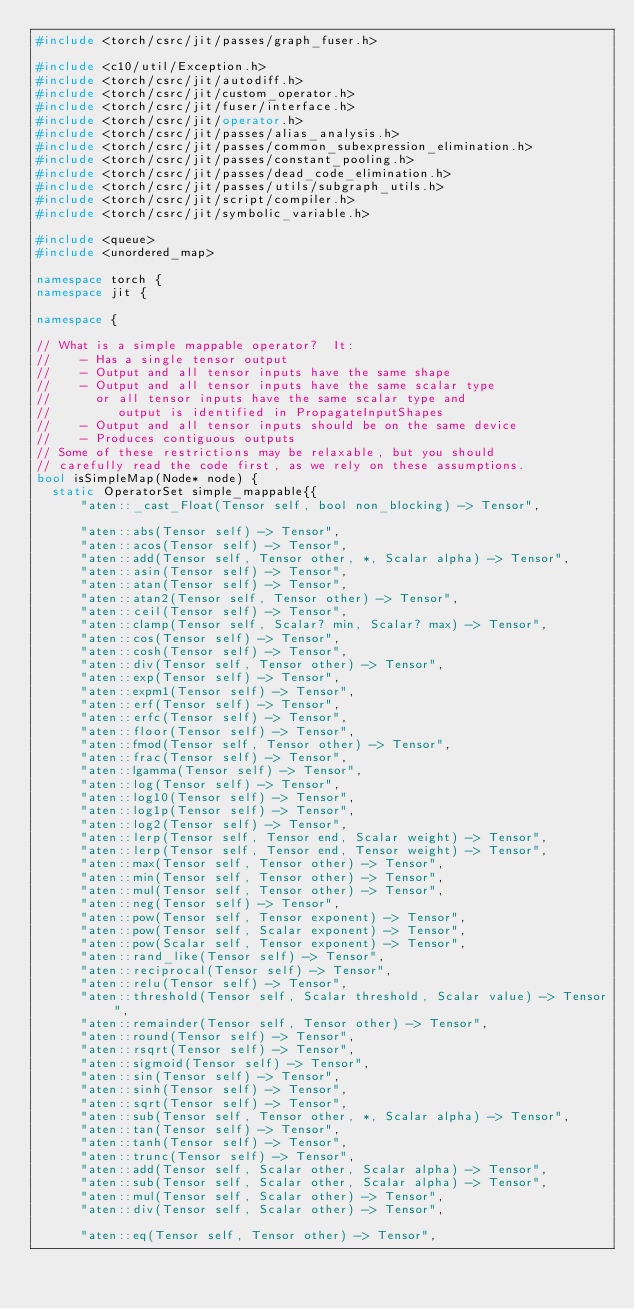Convert code to text. <code><loc_0><loc_0><loc_500><loc_500><_C++_>#include <torch/csrc/jit/passes/graph_fuser.h>

#include <c10/util/Exception.h>
#include <torch/csrc/jit/autodiff.h>
#include <torch/csrc/jit/custom_operator.h>
#include <torch/csrc/jit/fuser/interface.h>
#include <torch/csrc/jit/operator.h>
#include <torch/csrc/jit/passes/alias_analysis.h>
#include <torch/csrc/jit/passes/common_subexpression_elimination.h>
#include <torch/csrc/jit/passes/constant_pooling.h>
#include <torch/csrc/jit/passes/dead_code_elimination.h>
#include <torch/csrc/jit/passes/utils/subgraph_utils.h>
#include <torch/csrc/jit/script/compiler.h>
#include <torch/csrc/jit/symbolic_variable.h>

#include <queue>
#include <unordered_map>

namespace torch {
namespace jit {

namespace {

// What is a simple mappable operator?  It:
//    - Has a single tensor output
//    - Output and all tensor inputs have the same shape
//    - Output and all tensor inputs have the same scalar type
//      or all tensor inputs have the same scalar type and
//         output is identified in PropagateInputShapes
//    - Output and all tensor inputs should be on the same device
//    - Produces contiguous outputs
// Some of these restrictions may be relaxable, but you should
// carefully read the code first, as we rely on these assumptions.
bool isSimpleMap(Node* node) {
  static OperatorSet simple_mappable{{
      "aten::_cast_Float(Tensor self, bool non_blocking) -> Tensor",

      "aten::abs(Tensor self) -> Tensor",
      "aten::acos(Tensor self) -> Tensor",
      "aten::add(Tensor self, Tensor other, *, Scalar alpha) -> Tensor",
      "aten::asin(Tensor self) -> Tensor",
      "aten::atan(Tensor self) -> Tensor",
      "aten::atan2(Tensor self, Tensor other) -> Tensor",
      "aten::ceil(Tensor self) -> Tensor",
      "aten::clamp(Tensor self, Scalar? min, Scalar? max) -> Tensor",
      "aten::cos(Tensor self) -> Tensor",
      "aten::cosh(Tensor self) -> Tensor",
      "aten::div(Tensor self, Tensor other) -> Tensor",
      "aten::exp(Tensor self) -> Tensor",
      "aten::expm1(Tensor self) -> Tensor",
      "aten::erf(Tensor self) -> Tensor",
      "aten::erfc(Tensor self) -> Tensor",
      "aten::floor(Tensor self) -> Tensor",
      "aten::fmod(Tensor self, Tensor other) -> Tensor",
      "aten::frac(Tensor self) -> Tensor",
      "aten::lgamma(Tensor self) -> Tensor",
      "aten::log(Tensor self) -> Tensor",
      "aten::log10(Tensor self) -> Tensor",
      "aten::log1p(Tensor self) -> Tensor",
      "aten::log2(Tensor self) -> Tensor",
      "aten::lerp(Tensor self, Tensor end, Scalar weight) -> Tensor",
      "aten::lerp(Tensor self, Tensor end, Tensor weight) -> Tensor",
      "aten::max(Tensor self, Tensor other) -> Tensor",
      "aten::min(Tensor self, Tensor other) -> Tensor",
      "aten::mul(Tensor self, Tensor other) -> Tensor",
      "aten::neg(Tensor self) -> Tensor",
      "aten::pow(Tensor self, Tensor exponent) -> Tensor",
      "aten::pow(Tensor self, Scalar exponent) -> Tensor",
      "aten::pow(Scalar self, Tensor exponent) -> Tensor",
      "aten::rand_like(Tensor self) -> Tensor",
      "aten::reciprocal(Tensor self) -> Tensor",
      "aten::relu(Tensor self) -> Tensor",
      "aten::threshold(Tensor self, Scalar threshold, Scalar value) -> Tensor",
      "aten::remainder(Tensor self, Tensor other) -> Tensor",
      "aten::round(Tensor self) -> Tensor",
      "aten::rsqrt(Tensor self) -> Tensor",
      "aten::sigmoid(Tensor self) -> Tensor",
      "aten::sin(Tensor self) -> Tensor",
      "aten::sinh(Tensor self) -> Tensor",
      "aten::sqrt(Tensor self) -> Tensor",
      "aten::sub(Tensor self, Tensor other, *, Scalar alpha) -> Tensor",
      "aten::tan(Tensor self) -> Tensor",
      "aten::tanh(Tensor self) -> Tensor",
      "aten::trunc(Tensor self) -> Tensor",
      "aten::add(Tensor self, Scalar other, Scalar alpha) -> Tensor",
      "aten::sub(Tensor self, Scalar other, Scalar alpha) -> Tensor",
      "aten::mul(Tensor self, Scalar other) -> Tensor",
      "aten::div(Tensor self, Scalar other) -> Tensor",

      "aten::eq(Tensor self, Tensor other) -> Tensor",</code> 